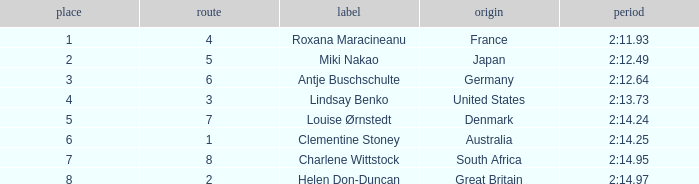What is the number of lane with a rank more than 2 for louise ørnstedt? 1.0. 